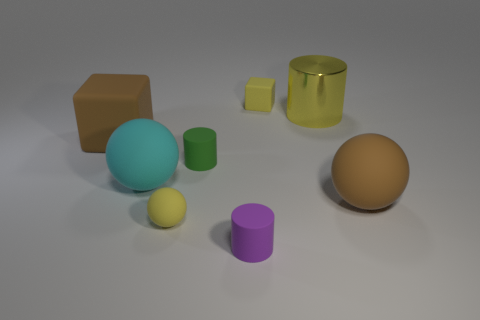Add 1 cubes. How many objects exist? 9 Subtract all balls. How many objects are left? 5 Subtract all small matte blocks. Subtract all yellow metal things. How many objects are left? 6 Add 8 rubber cylinders. How many rubber cylinders are left? 10 Add 8 metallic cylinders. How many metallic cylinders exist? 9 Subtract 0 cyan cylinders. How many objects are left? 8 